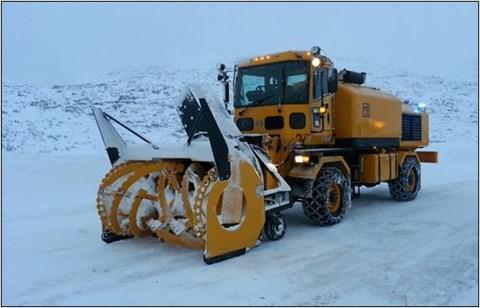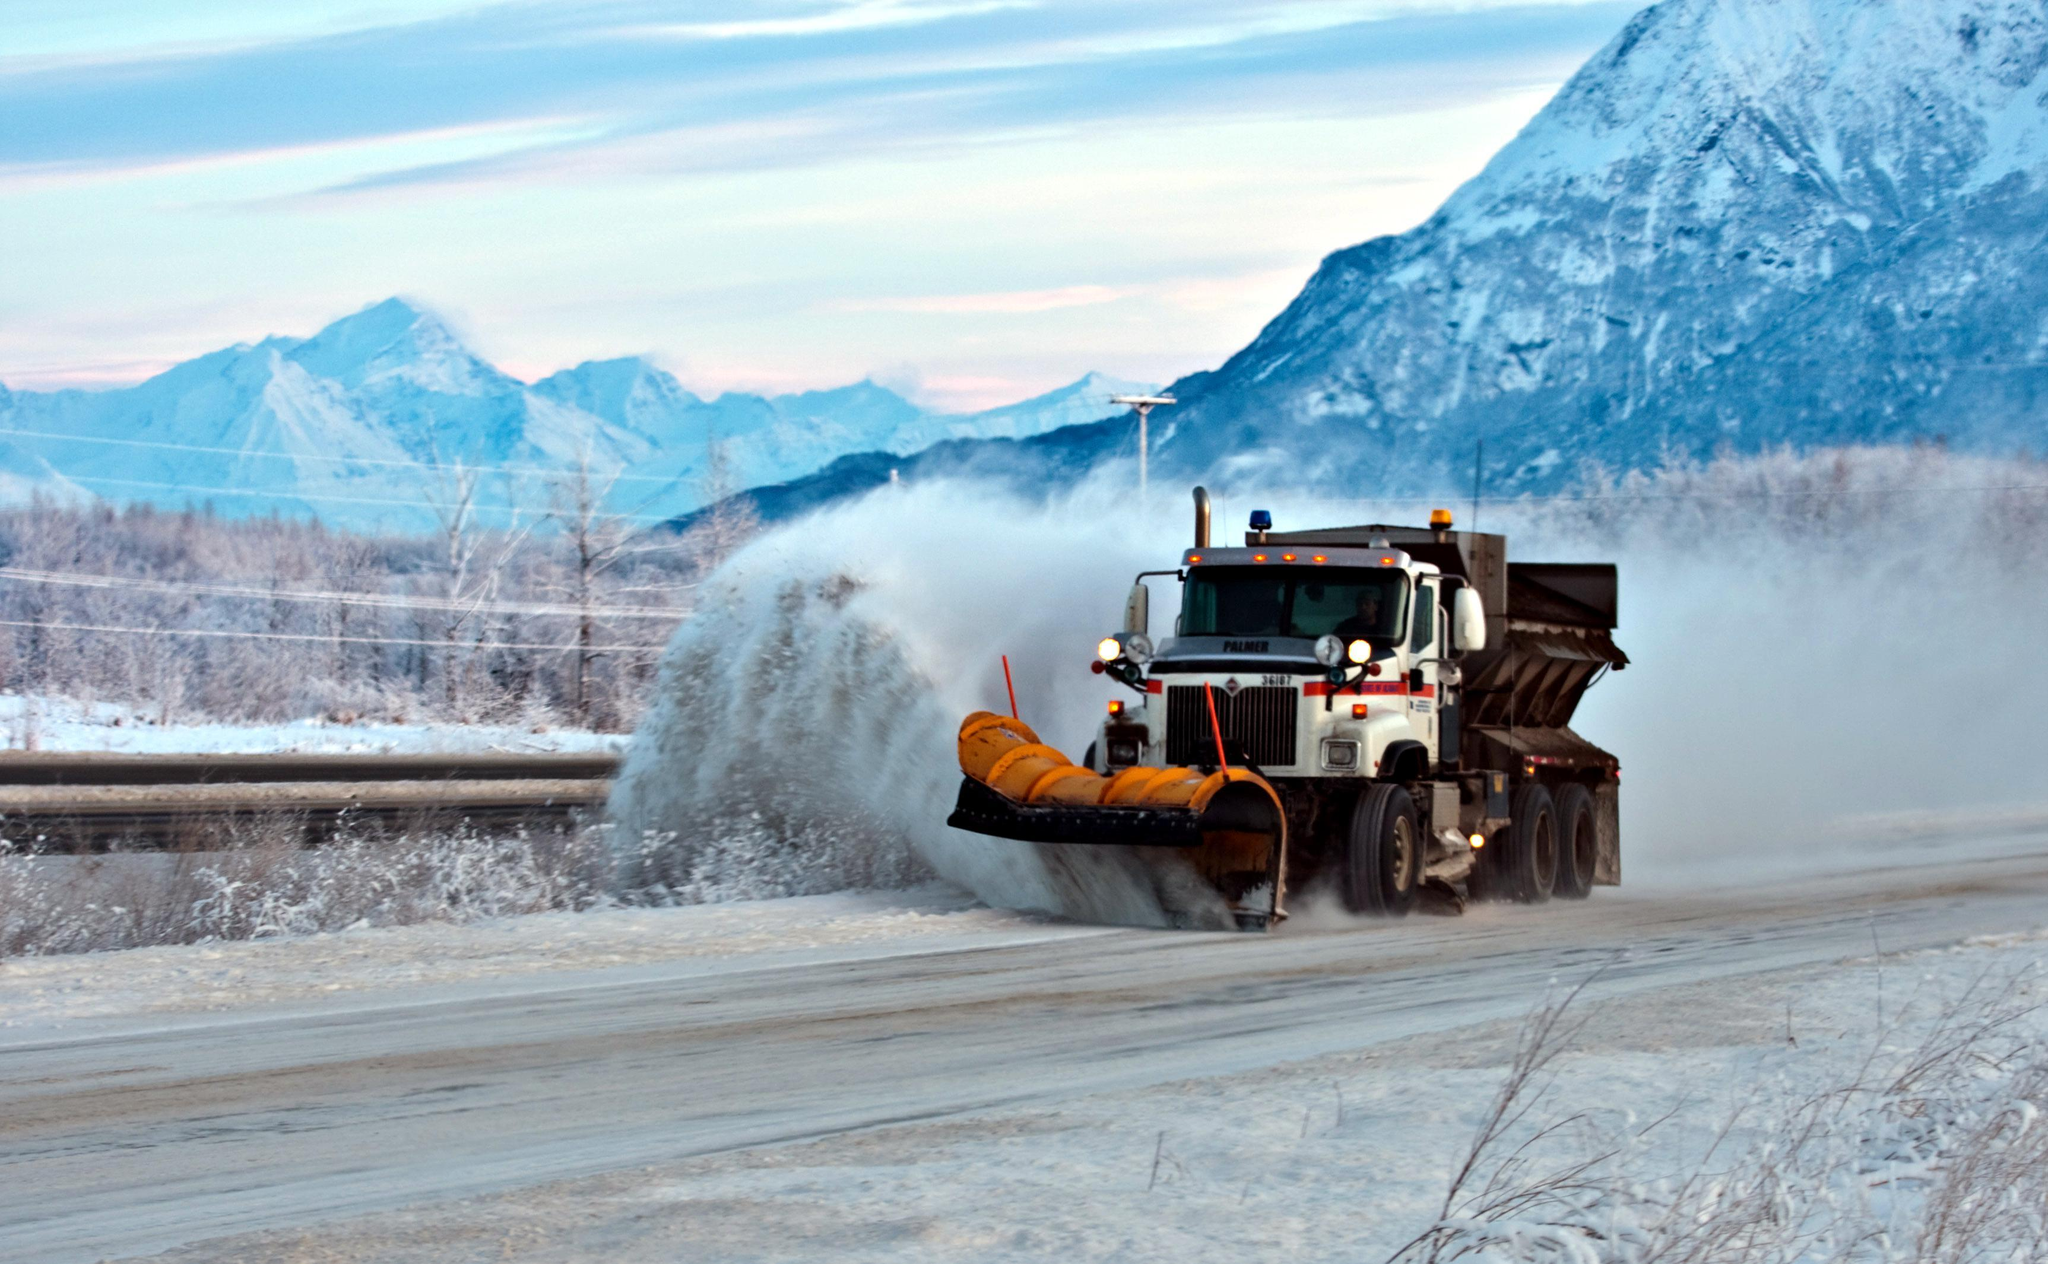The first image is the image on the left, the second image is the image on the right. Examine the images to the left and right. Is the description "The vehicle in the right image is driving in front of a house" accurate? Answer yes or no. No. 